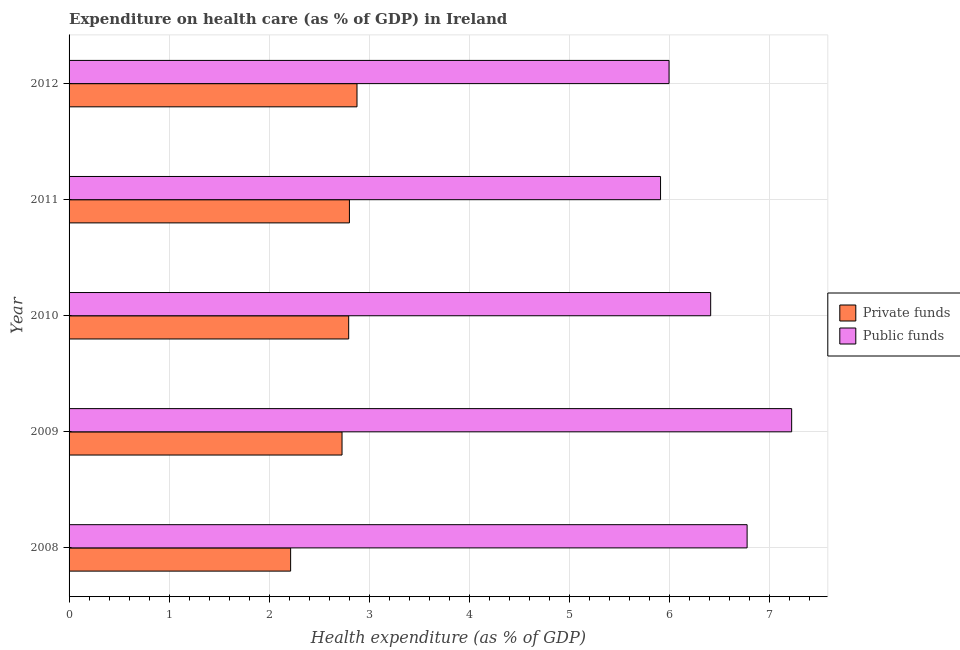How many different coloured bars are there?
Your response must be concise. 2. Are the number of bars per tick equal to the number of legend labels?
Keep it short and to the point. Yes. Are the number of bars on each tick of the Y-axis equal?
Provide a short and direct response. Yes. How many bars are there on the 1st tick from the top?
Your answer should be compact. 2. How many bars are there on the 2nd tick from the bottom?
Give a very brief answer. 2. What is the label of the 4th group of bars from the top?
Your answer should be compact. 2009. What is the amount of private funds spent in healthcare in 2008?
Make the answer very short. 2.21. Across all years, what is the maximum amount of private funds spent in healthcare?
Offer a very short reply. 2.88. Across all years, what is the minimum amount of public funds spent in healthcare?
Provide a succinct answer. 5.91. In which year was the amount of public funds spent in healthcare maximum?
Your answer should be compact. 2009. What is the total amount of public funds spent in healthcare in the graph?
Your answer should be compact. 32.32. What is the difference between the amount of public funds spent in healthcare in 2008 and that in 2011?
Your response must be concise. 0.86. What is the difference between the amount of public funds spent in healthcare in 2011 and the amount of private funds spent in healthcare in 2012?
Give a very brief answer. 3.03. What is the average amount of private funds spent in healthcare per year?
Your answer should be very brief. 2.68. In the year 2008, what is the difference between the amount of private funds spent in healthcare and amount of public funds spent in healthcare?
Ensure brevity in your answer.  -4.56. In how many years, is the amount of public funds spent in healthcare greater than 5.6 %?
Keep it short and to the point. 5. What is the ratio of the amount of public funds spent in healthcare in 2008 to that in 2012?
Ensure brevity in your answer.  1.13. Is the amount of private funds spent in healthcare in 2008 less than that in 2009?
Make the answer very short. Yes. What is the difference between the highest and the second highest amount of private funds spent in healthcare?
Make the answer very short. 0.08. What is the difference between the highest and the lowest amount of private funds spent in healthcare?
Provide a short and direct response. 0.66. In how many years, is the amount of public funds spent in healthcare greater than the average amount of public funds spent in healthcare taken over all years?
Provide a succinct answer. 2. Is the sum of the amount of private funds spent in healthcare in 2010 and 2012 greater than the maximum amount of public funds spent in healthcare across all years?
Ensure brevity in your answer.  No. What does the 1st bar from the top in 2012 represents?
Your answer should be compact. Public funds. What does the 2nd bar from the bottom in 2008 represents?
Your answer should be very brief. Public funds. What is the difference between two consecutive major ticks on the X-axis?
Give a very brief answer. 1. Does the graph contain grids?
Provide a succinct answer. Yes. How many legend labels are there?
Your answer should be compact. 2. How are the legend labels stacked?
Your answer should be compact. Vertical. What is the title of the graph?
Offer a very short reply. Expenditure on health care (as % of GDP) in Ireland. Does "Food" appear as one of the legend labels in the graph?
Make the answer very short. No. What is the label or title of the X-axis?
Offer a very short reply. Health expenditure (as % of GDP). What is the Health expenditure (as % of GDP) of Private funds in 2008?
Offer a terse response. 2.21. What is the Health expenditure (as % of GDP) in Public funds in 2008?
Your answer should be compact. 6.78. What is the Health expenditure (as % of GDP) of Private funds in 2009?
Ensure brevity in your answer.  2.73. What is the Health expenditure (as % of GDP) of Public funds in 2009?
Ensure brevity in your answer.  7.22. What is the Health expenditure (as % of GDP) in Private funds in 2010?
Ensure brevity in your answer.  2.79. What is the Health expenditure (as % of GDP) in Public funds in 2010?
Provide a short and direct response. 6.41. What is the Health expenditure (as % of GDP) in Private funds in 2011?
Keep it short and to the point. 2.8. What is the Health expenditure (as % of GDP) in Public funds in 2011?
Provide a succinct answer. 5.91. What is the Health expenditure (as % of GDP) in Private funds in 2012?
Keep it short and to the point. 2.88. What is the Health expenditure (as % of GDP) in Public funds in 2012?
Provide a short and direct response. 6. Across all years, what is the maximum Health expenditure (as % of GDP) of Private funds?
Offer a terse response. 2.88. Across all years, what is the maximum Health expenditure (as % of GDP) in Public funds?
Ensure brevity in your answer.  7.22. Across all years, what is the minimum Health expenditure (as % of GDP) in Private funds?
Your answer should be very brief. 2.21. Across all years, what is the minimum Health expenditure (as % of GDP) of Public funds?
Keep it short and to the point. 5.91. What is the total Health expenditure (as % of GDP) of Private funds in the graph?
Make the answer very short. 13.42. What is the total Health expenditure (as % of GDP) of Public funds in the graph?
Provide a succinct answer. 32.32. What is the difference between the Health expenditure (as % of GDP) of Private funds in 2008 and that in 2009?
Provide a short and direct response. -0.51. What is the difference between the Health expenditure (as % of GDP) of Public funds in 2008 and that in 2009?
Ensure brevity in your answer.  -0.45. What is the difference between the Health expenditure (as % of GDP) in Private funds in 2008 and that in 2010?
Offer a very short reply. -0.58. What is the difference between the Health expenditure (as % of GDP) in Public funds in 2008 and that in 2010?
Provide a succinct answer. 0.36. What is the difference between the Health expenditure (as % of GDP) of Private funds in 2008 and that in 2011?
Your answer should be very brief. -0.59. What is the difference between the Health expenditure (as % of GDP) of Public funds in 2008 and that in 2011?
Offer a very short reply. 0.87. What is the difference between the Health expenditure (as % of GDP) in Private funds in 2008 and that in 2012?
Your answer should be compact. -0.66. What is the difference between the Health expenditure (as % of GDP) in Public funds in 2008 and that in 2012?
Provide a short and direct response. 0.78. What is the difference between the Health expenditure (as % of GDP) in Private funds in 2009 and that in 2010?
Provide a succinct answer. -0.07. What is the difference between the Health expenditure (as % of GDP) of Public funds in 2009 and that in 2010?
Provide a succinct answer. 0.81. What is the difference between the Health expenditure (as % of GDP) of Private funds in 2009 and that in 2011?
Provide a succinct answer. -0.07. What is the difference between the Health expenditure (as % of GDP) of Public funds in 2009 and that in 2011?
Your response must be concise. 1.31. What is the difference between the Health expenditure (as % of GDP) of Private funds in 2009 and that in 2012?
Give a very brief answer. -0.15. What is the difference between the Health expenditure (as % of GDP) in Public funds in 2009 and that in 2012?
Make the answer very short. 1.23. What is the difference between the Health expenditure (as % of GDP) of Private funds in 2010 and that in 2011?
Offer a very short reply. -0.01. What is the difference between the Health expenditure (as % of GDP) in Public funds in 2010 and that in 2011?
Make the answer very short. 0.5. What is the difference between the Health expenditure (as % of GDP) of Private funds in 2010 and that in 2012?
Ensure brevity in your answer.  -0.08. What is the difference between the Health expenditure (as % of GDP) in Public funds in 2010 and that in 2012?
Offer a very short reply. 0.42. What is the difference between the Health expenditure (as % of GDP) in Private funds in 2011 and that in 2012?
Offer a very short reply. -0.08. What is the difference between the Health expenditure (as % of GDP) of Public funds in 2011 and that in 2012?
Offer a very short reply. -0.09. What is the difference between the Health expenditure (as % of GDP) in Private funds in 2008 and the Health expenditure (as % of GDP) in Public funds in 2009?
Ensure brevity in your answer.  -5.01. What is the difference between the Health expenditure (as % of GDP) in Private funds in 2008 and the Health expenditure (as % of GDP) in Public funds in 2010?
Offer a very short reply. -4.2. What is the difference between the Health expenditure (as % of GDP) of Private funds in 2008 and the Health expenditure (as % of GDP) of Public funds in 2011?
Your answer should be compact. -3.7. What is the difference between the Health expenditure (as % of GDP) in Private funds in 2008 and the Health expenditure (as % of GDP) in Public funds in 2012?
Your answer should be very brief. -3.78. What is the difference between the Health expenditure (as % of GDP) in Private funds in 2009 and the Health expenditure (as % of GDP) in Public funds in 2010?
Offer a very short reply. -3.68. What is the difference between the Health expenditure (as % of GDP) of Private funds in 2009 and the Health expenditure (as % of GDP) of Public funds in 2011?
Offer a very short reply. -3.18. What is the difference between the Health expenditure (as % of GDP) of Private funds in 2009 and the Health expenditure (as % of GDP) of Public funds in 2012?
Give a very brief answer. -3.27. What is the difference between the Health expenditure (as % of GDP) of Private funds in 2010 and the Health expenditure (as % of GDP) of Public funds in 2011?
Your answer should be very brief. -3.12. What is the difference between the Health expenditure (as % of GDP) of Private funds in 2010 and the Health expenditure (as % of GDP) of Public funds in 2012?
Give a very brief answer. -3.2. What is the difference between the Health expenditure (as % of GDP) in Private funds in 2011 and the Health expenditure (as % of GDP) in Public funds in 2012?
Offer a very short reply. -3.19. What is the average Health expenditure (as % of GDP) of Private funds per year?
Provide a succinct answer. 2.68. What is the average Health expenditure (as % of GDP) of Public funds per year?
Offer a very short reply. 6.46. In the year 2008, what is the difference between the Health expenditure (as % of GDP) of Private funds and Health expenditure (as % of GDP) of Public funds?
Provide a short and direct response. -4.56. In the year 2009, what is the difference between the Health expenditure (as % of GDP) in Private funds and Health expenditure (as % of GDP) in Public funds?
Keep it short and to the point. -4.49. In the year 2010, what is the difference between the Health expenditure (as % of GDP) of Private funds and Health expenditure (as % of GDP) of Public funds?
Provide a short and direct response. -3.62. In the year 2011, what is the difference between the Health expenditure (as % of GDP) of Private funds and Health expenditure (as % of GDP) of Public funds?
Provide a succinct answer. -3.11. In the year 2012, what is the difference between the Health expenditure (as % of GDP) of Private funds and Health expenditure (as % of GDP) of Public funds?
Offer a very short reply. -3.12. What is the ratio of the Health expenditure (as % of GDP) of Private funds in 2008 to that in 2009?
Your answer should be very brief. 0.81. What is the ratio of the Health expenditure (as % of GDP) of Public funds in 2008 to that in 2009?
Your answer should be compact. 0.94. What is the ratio of the Health expenditure (as % of GDP) in Private funds in 2008 to that in 2010?
Offer a terse response. 0.79. What is the ratio of the Health expenditure (as % of GDP) in Public funds in 2008 to that in 2010?
Ensure brevity in your answer.  1.06. What is the ratio of the Health expenditure (as % of GDP) in Private funds in 2008 to that in 2011?
Make the answer very short. 0.79. What is the ratio of the Health expenditure (as % of GDP) in Public funds in 2008 to that in 2011?
Provide a short and direct response. 1.15. What is the ratio of the Health expenditure (as % of GDP) in Private funds in 2008 to that in 2012?
Ensure brevity in your answer.  0.77. What is the ratio of the Health expenditure (as % of GDP) in Public funds in 2008 to that in 2012?
Provide a short and direct response. 1.13. What is the ratio of the Health expenditure (as % of GDP) of Private funds in 2009 to that in 2010?
Provide a succinct answer. 0.98. What is the ratio of the Health expenditure (as % of GDP) of Public funds in 2009 to that in 2010?
Offer a very short reply. 1.13. What is the ratio of the Health expenditure (as % of GDP) in Private funds in 2009 to that in 2011?
Keep it short and to the point. 0.97. What is the ratio of the Health expenditure (as % of GDP) in Public funds in 2009 to that in 2011?
Make the answer very short. 1.22. What is the ratio of the Health expenditure (as % of GDP) in Private funds in 2009 to that in 2012?
Give a very brief answer. 0.95. What is the ratio of the Health expenditure (as % of GDP) in Public funds in 2009 to that in 2012?
Your answer should be very brief. 1.2. What is the ratio of the Health expenditure (as % of GDP) of Public funds in 2010 to that in 2011?
Your answer should be very brief. 1.08. What is the ratio of the Health expenditure (as % of GDP) in Private funds in 2010 to that in 2012?
Offer a terse response. 0.97. What is the ratio of the Health expenditure (as % of GDP) of Public funds in 2010 to that in 2012?
Your answer should be compact. 1.07. What is the ratio of the Health expenditure (as % of GDP) of Private funds in 2011 to that in 2012?
Provide a succinct answer. 0.97. What is the ratio of the Health expenditure (as % of GDP) in Public funds in 2011 to that in 2012?
Provide a succinct answer. 0.99. What is the difference between the highest and the second highest Health expenditure (as % of GDP) of Private funds?
Your answer should be very brief. 0.08. What is the difference between the highest and the second highest Health expenditure (as % of GDP) of Public funds?
Offer a very short reply. 0.45. What is the difference between the highest and the lowest Health expenditure (as % of GDP) in Private funds?
Provide a succinct answer. 0.66. What is the difference between the highest and the lowest Health expenditure (as % of GDP) in Public funds?
Your answer should be compact. 1.31. 